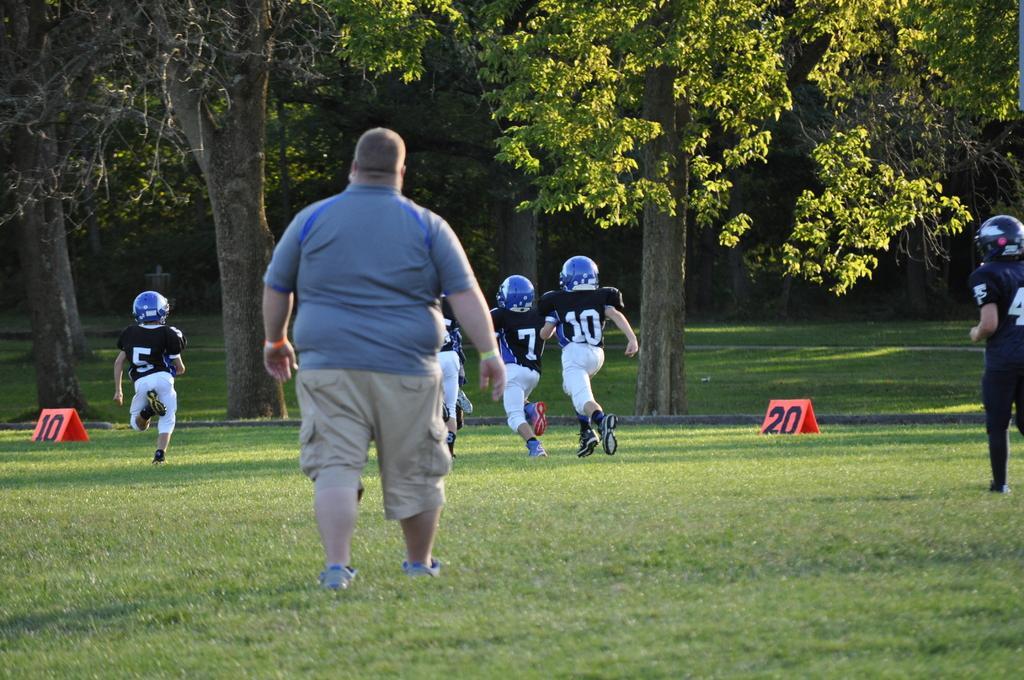Please provide a concise description of this image. In this image I can see few people and wearing different color dress. Back I can see a trees and red color board on the ground. 